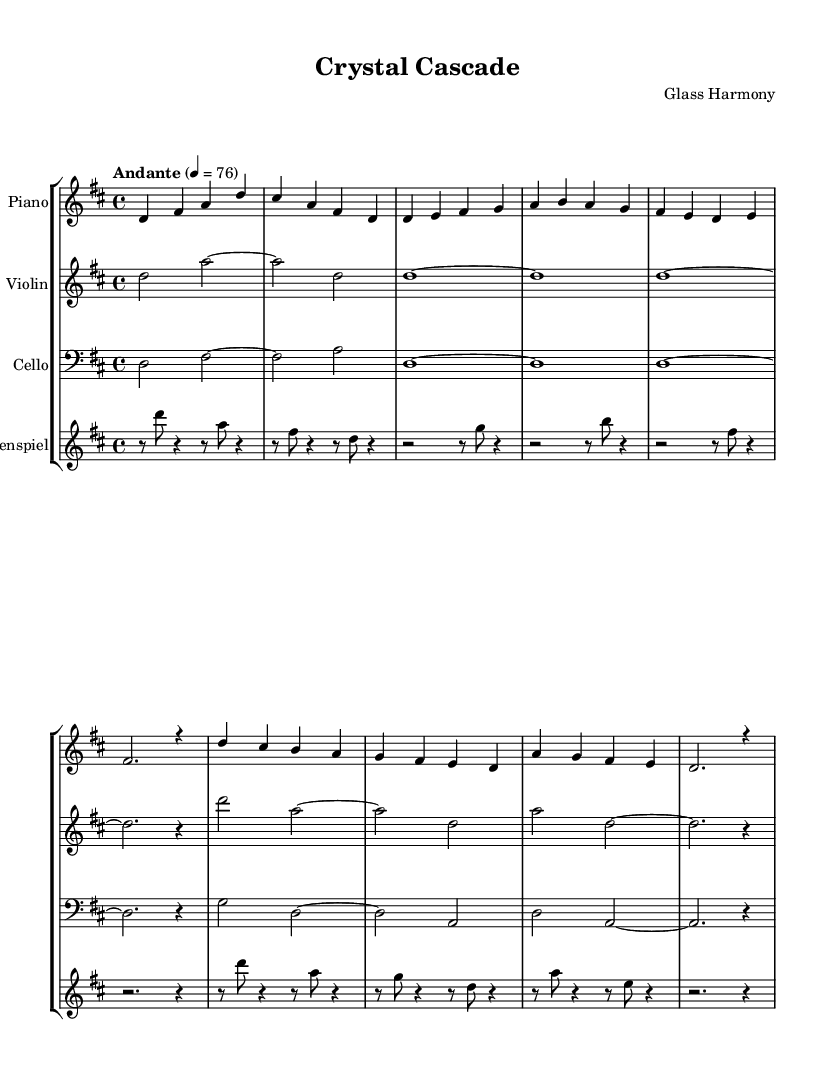What is the key signature of this music? The key signature is D major, which has two sharps: F# and C#. This can be identified by looking at the key signature at the beginning of the staff.
Answer: D major What is the time signature of this piece? The time signature is 4/4, which can be found at the beginning of the staff right after the key signature. This means there are four beats in each measure and the quarter note gets one beat.
Answer: 4/4 What is the tempo marking for this composition? The tempo marking indicates "Andante," which generally means a moderate walking pace. This is specified right before the measure numbers, indicating how fast the piece should be played.
Answer: Andante How many instruments are used in this composition? There are four distinct instruments indicated on the score: Piano, Violin, Cello, and Glockenspiel. Each instrument has its own staff that shows the specific music notation for it.
Answer: Four Which instrument plays the lowest notes in this piece? The Cello plays the lowest notes since it is notated in the bass clef and typically has a lower pitch range compared to the other instruments. By identifying the clefs, we can deduce that the cello will sound the lowest.
Answer: Cello What is the rhythmic pattern used in the glockenspiel part? The rhythmic pattern consists mostly of eighth notes and quarter notes, reflecting a gentle and flowing style in line with the theme of glass art and light refraction. By analyzing the notes and their values in the glockenspiel part, we see a mix of shorter and longer notes.
Answer: Eighth and quarter notes What is the highest pitch note in the score? The highest pitch note is A in the violin part, located above the treble staff. By looking at the notes played by each instrument, we can identify A as the peak pitch throughout the composition.
Answer: A 